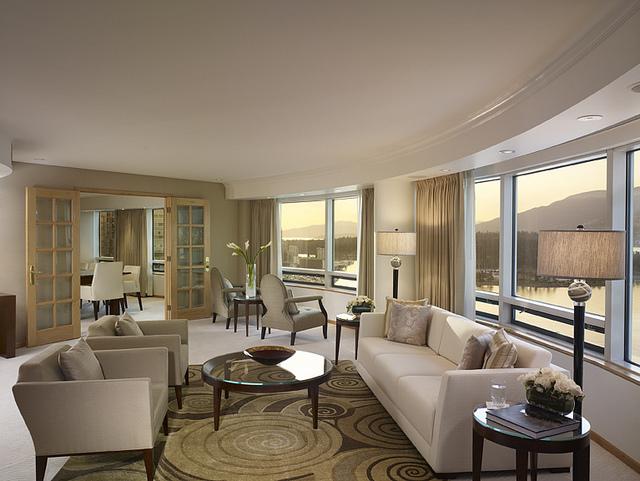What kind of flowers are in the long vase?
Answer briefly. Lilies. Is it day or night?
Write a very short answer. Day. What design is on the rug?
Short answer required. Circles. 